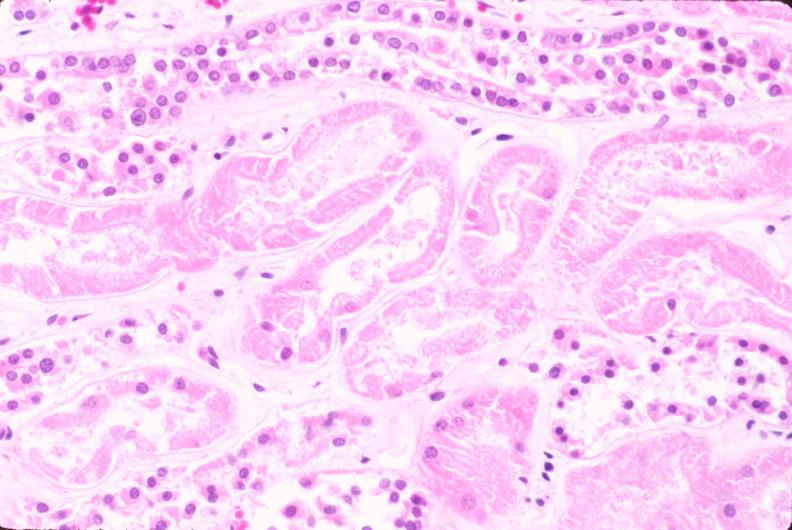does glioma show kidney, acute tubular necrosis?
Answer the question using a single word or phrase. No 